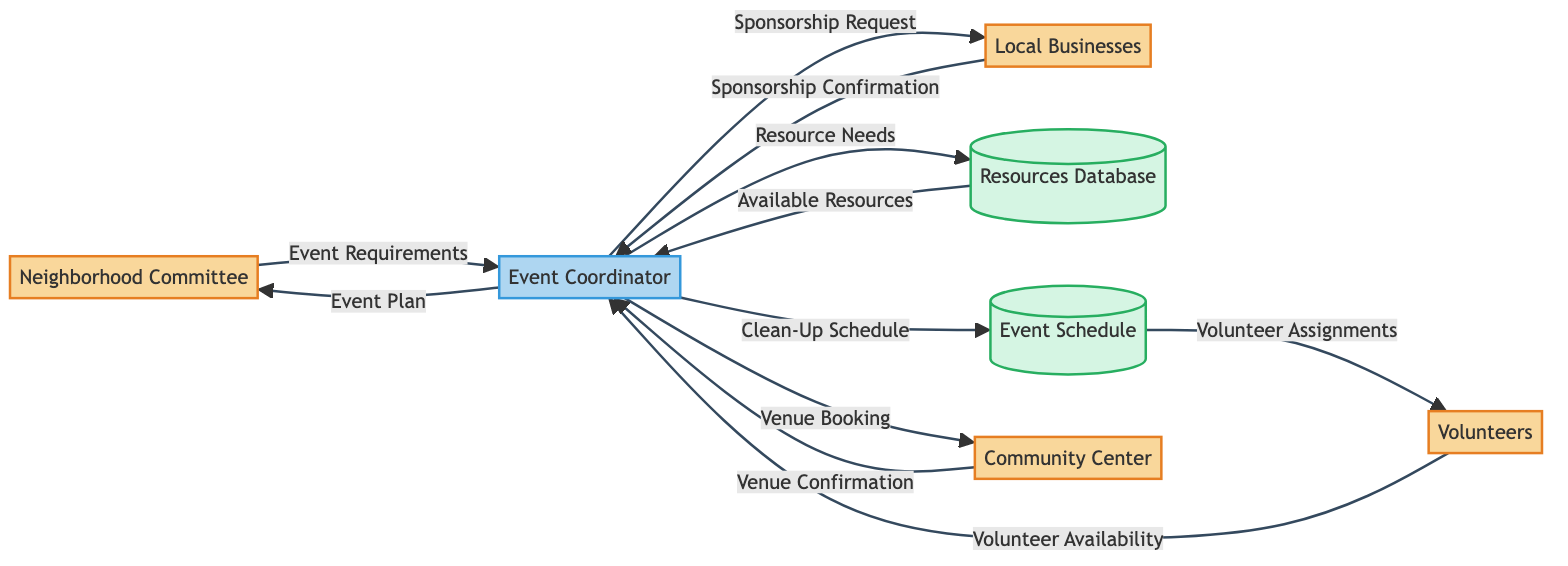What external entity sends the Event Requirements? The diagram shows an arrow from the Neighborhood Committee to the Event Coordinator labeled "Event Requirements." Therefore, the Neighborhood Committee is the external entity that sends this information.
Answer: Neighborhood Committee How many data stores are present in the diagram? The diagram features two data stores: Resources Database and Event Schedule. By counting these, we determine there are two.
Answer: 2 What data flows from Volunteers to Event Coordinator? The diagram indicates a flow from Volunteers to Event Coordinator labeled "Volunteer Availability." This shows that Volunteers provide this information to the Event Coordinator.
Answer: Volunteer Availability Which external entity confirms the venue? According to the diagram, the Community Center sends "Venue Confirmation" to the Event Coordinator. Thus, the Community Center is the entity that confirms the venue.
Answer: Community Center What is the first piece of data sent to the Event Coordinator? The first data flow to the Event Coordinator is the "Event Requirements" from the Neighborhood Committee, as depicted in the diagram.
Answer: Event Requirements What does the Event Coordinator send to Local Businesses? The arrow from Event Coordinator to Local Businesses is labeled "Sponsorship Request." This indicates that the Event Coordinator sends this data to Local Businesses.
Answer: Sponsorship Request List all entities involved in this process. By reviewing the diagram, the entities include Neighborhood Committee, Volunteers, Local Businesses, and Community Center. Collectively, these four entities are involved in the process.
Answer: Neighborhood Committee, Volunteers, Local Businesses, Community Center How is the Event Schedule updated? The Event Coordinator provides the "Clean-Up Schedule" to the Event Schedule data store. This shows the method by which the Event Schedule is updated in the process.
Answer: Clean-Up Schedule What data does the Resources Database provide to the Event Coordinator? The Resources Database sends "Available Resources" to the Event Coordinator, as indicated by the arrow in the diagram, showcasing the data flow.
Answer: Available Resources 